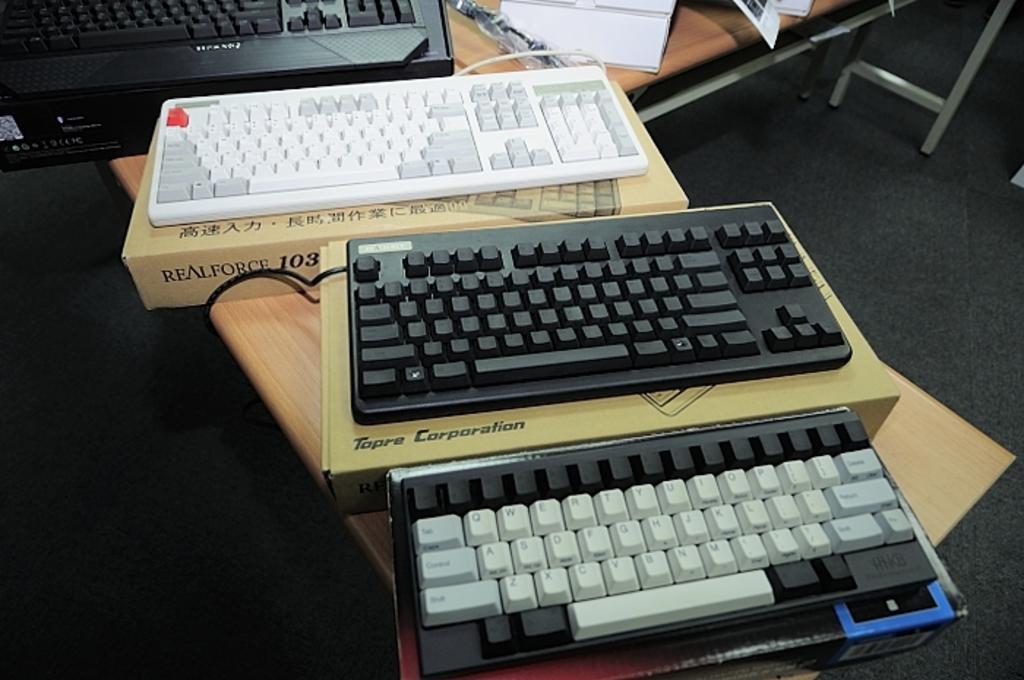How would you summarize this image in a sentence or two? In this picture we can see table and on table we have three keyboards and boxes of that and in background we can see some more keyboard, papers, stand. 